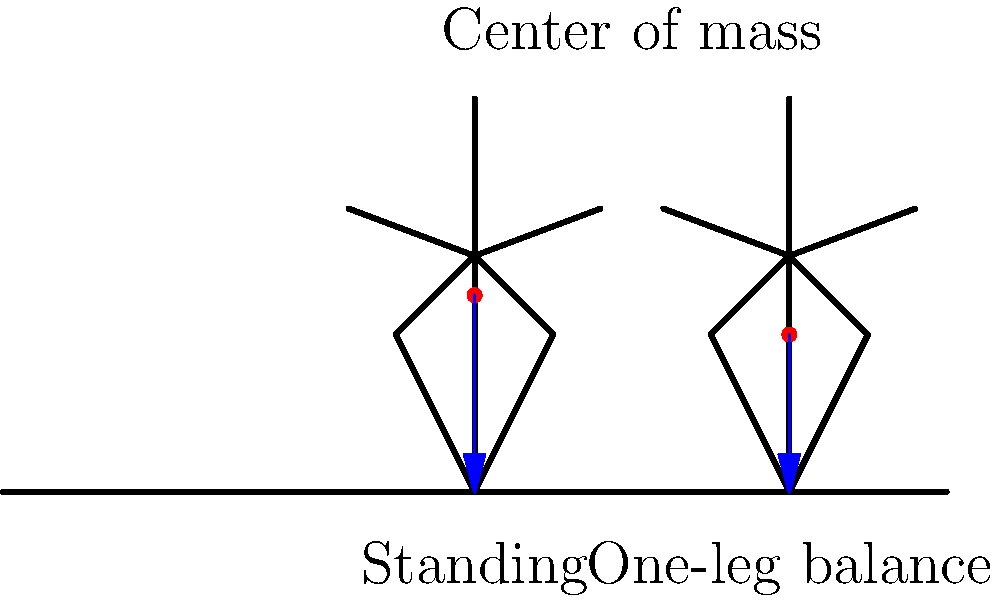As a manager implementing new balance training exercises for your team's wellness program, you notice differences in the center of mass locations during various poses. Based on the diagram showing two balance positions, how does the center of mass shift when moving from a standing position to a one-leg balance, and what implications might this have for employee stability and safety during the exercise? To understand the shift in center of mass and its implications, let's analyze the diagram step-by-step:

1. Standing position:
   - The center of mass (red dot) is located higher, approximately at the body's midpoint.
   - The force vector (blue arrow) is vertical and centered.

2. One-leg balance position:
   - The center of mass is lower compared to the standing position.
   - The force vector is still vertical but shifted towards the supporting leg.

3. Center of mass shift:
   - Vertical shift: The center of mass moves downward.
   - Horizontal shift: The center of mass moves laterally towards the supporting leg.

4. Implications for stability:
   - Lower center of mass generally increases stability by reducing the moment arm for tipping.
   - Lateral shift challenges balance, requiring more muscular engagement to maintain posture.

5. Safety considerations:
   - Increased muscle activation may lead to fatigue if held for extended periods.
   - Risk of falls may increase due to the reduced base of support (one foot instead of two).

6. Exercise benefits:
   - Improves proprioception and balance control.
   - Strengthens stabilizing muscles in the lower body and core.

7. Management implications:
   - Need for proper instruction and supervision during initial implementation.
   - Gradual progression from easier to more challenging balance exercises.
   - Ensuring a safe environment with support structures nearby (e.g., walls or chairs).

The shift in center of mass during this exercise challenges employees' balance systems, potentially improving their overall stability and reducing fall risks in the long term, but requires careful implementation to ensure safety during the training process.
Answer: The center of mass lowers and shifts laterally, increasing stability but challenging balance, requiring careful implementation for safety and effectiveness. 